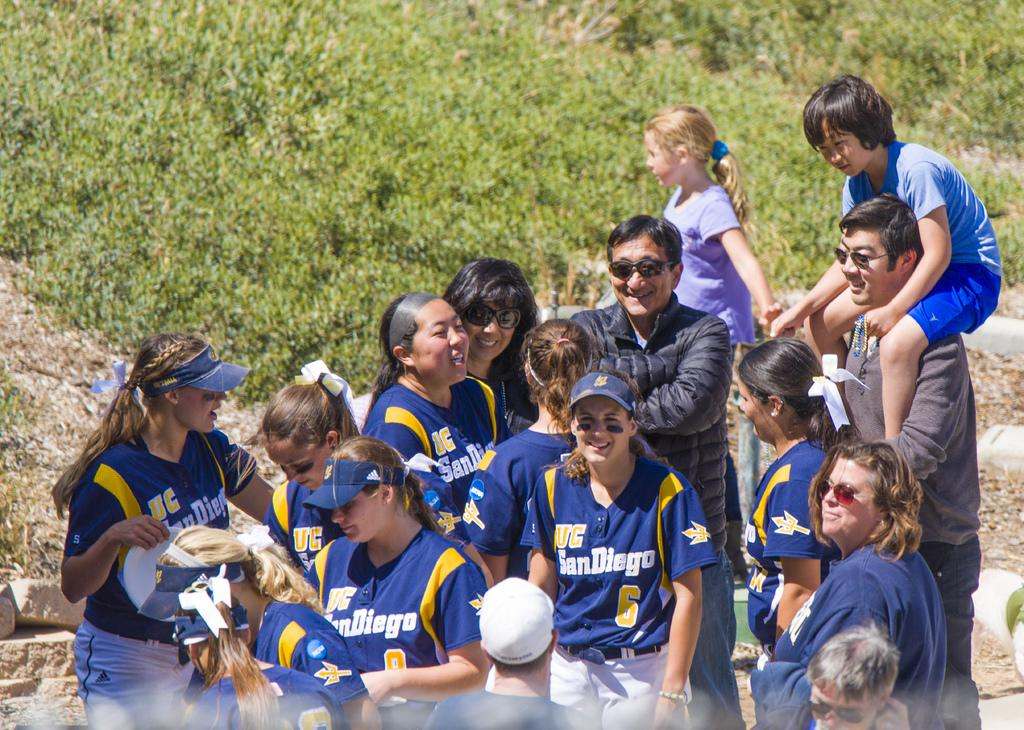What is the main subject of the image? The main subject of the image is people. Can you describe the people's expressions in the image? The people in the image are smiling. What can be seen in the background of the image? There is grass visible in the background of the image. How many pigs are running through the grass in the image? There are no pigs present in the image; it features people smiling in the center and grass in the background. 